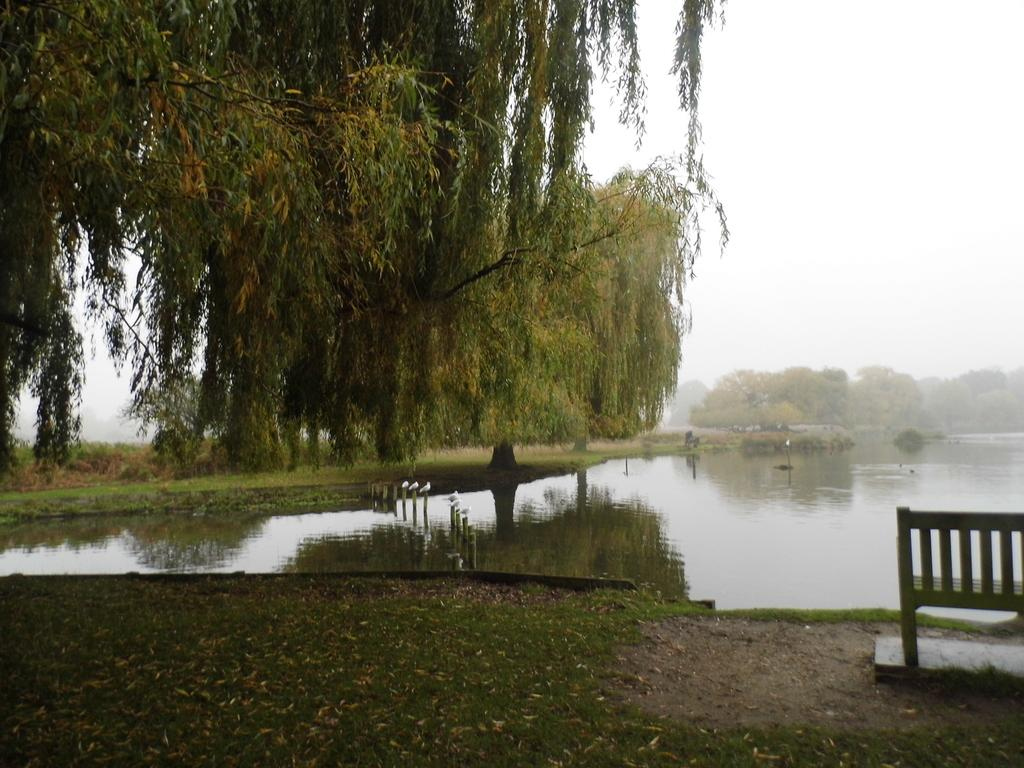What type of vegetation is present in the image? The image contains trees. What can be seen in the middle of the image? There is water in the middle of the image. What is visible at the bottom of the image? The ground is visible at the bottom of the image. Where is the bench located in the image? The bench is to the right of the image. What type of minister is depicted in the image? There is no minister present in the image; it features trees, water, ground, and a bench. What type of system is being used to manage the trees in the image? There is no system mentioned or depicted in the image; it simply shows trees, water, ground, and a bench. 